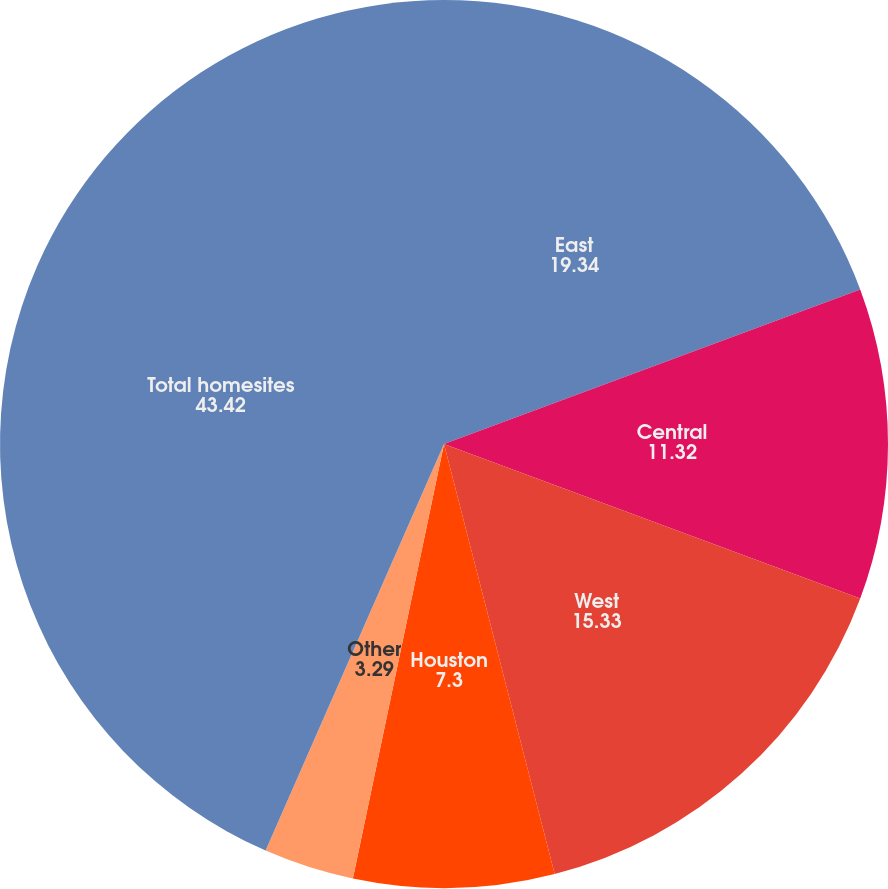Convert chart. <chart><loc_0><loc_0><loc_500><loc_500><pie_chart><fcel>East<fcel>Central<fcel>West<fcel>Houston<fcel>Other<fcel>Total homesites<nl><fcel>19.34%<fcel>11.32%<fcel>15.33%<fcel>7.3%<fcel>3.29%<fcel>43.42%<nl></chart> 